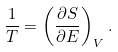<formula> <loc_0><loc_0><loc_500><loc_500>\frac { 1 } { T } = \left ( \frac { \partial S } { \partial E } \right ) _ { V } .</formula> 